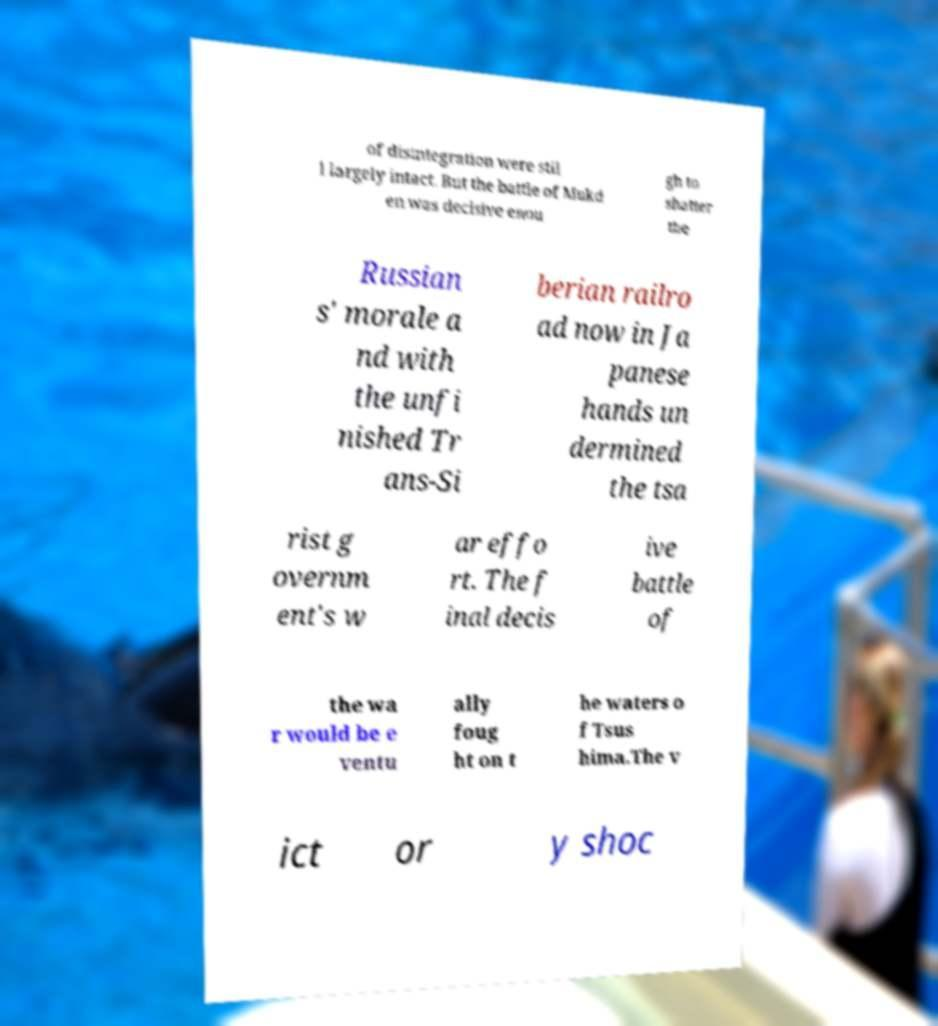Please identify and transcribe the text found in this image. of disintegration were stil l largely intact. But the battle of Mukd en was decisive enou gh to shatter the Russian s' morale a nd with the unfi nished Tr ans-Si berian railro ad now in Ja panese hands un dermined the tsa rist g overnm ent's w ar effo rt. The f inal decis ive battle of the wa r would be e ventu ally foug ht on t he waters o f Tsus hima.The v ict or y shoc 